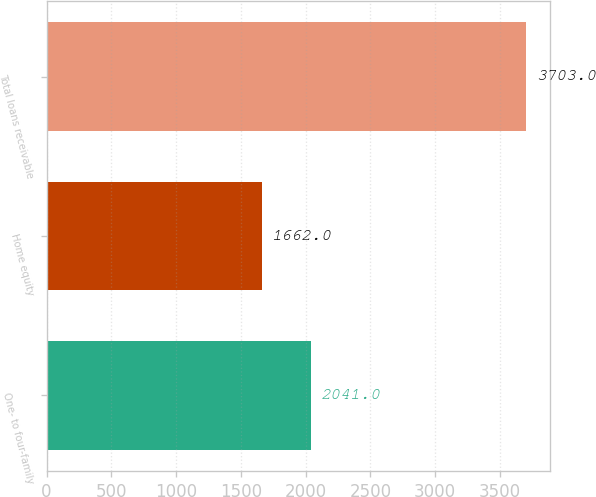Convert chart to OTSL. <chart><loc_0><loc_0><loc_500><loc_500><bar_chart><fcel>One- to four-family<fcel>Home equity<fcel>Total loans receivable<nl><fcel>2041<fcel>1662<fcel>3703<nl></chart> 